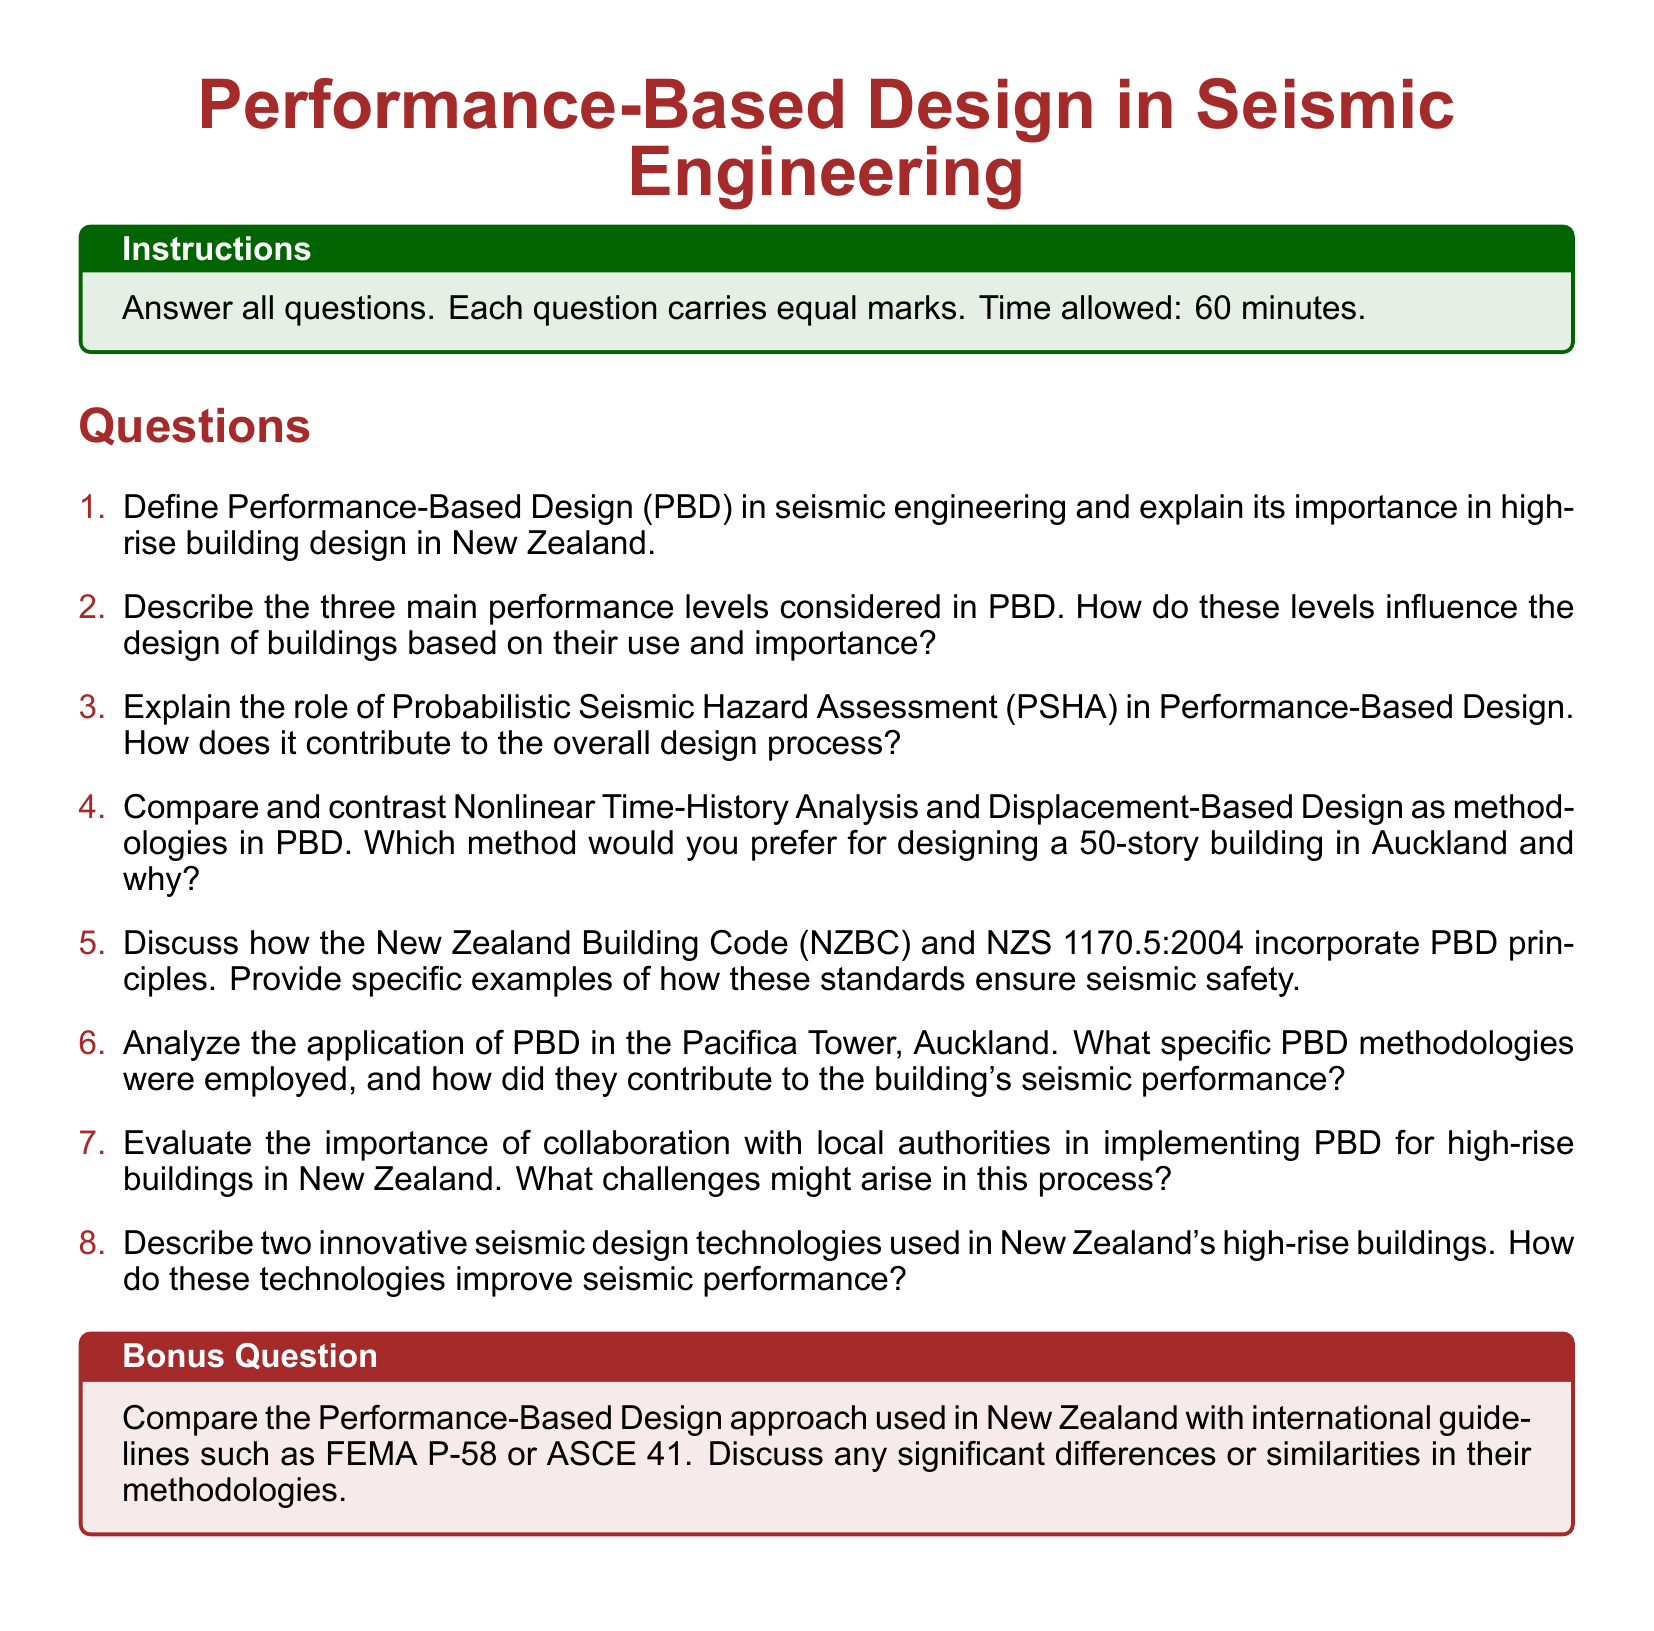What is the title of the document? The title of the document is prominently displayed at the top and states the main topic covered.
Answer: Performance-Based Design in Seismic Engineering What is the main focus of the exam? The exam focuses on performance-based seismic engineering design principles.
Answer: Performance-Based Design in Seismic Engineering How many minutes are allowed for the exam? The document specifies the time allowed to complete the exam.
Answer: 60 minutes What is the first question about? The first question asks for a definition and explanation of Performance-Based Design in seismic engineering.
Answer: Define Performance-Based Design What methodology is compared to Nonlinear Time-History Analysis? The document mentions another methodology in the context of Performance-Based Design which is used for comparison.
Answer: Displacement-Based Design What does the Bonus Question compare? The Bonus Question compares different Performance-Based Design approaches specifically in terms of methodologies.
Answer: New Zealand with international guidelines What is the significance of collaboration in PBD for high-rise buildings? The document mentions the importance of working together with local authorities in the implementation process.
Answer: Importance of collaboration Which building is analyzed in terms of PBD application? The document specifies a particular high-rise building located in Auckland that serves as a case study.
Answer: Pacifica Tower 